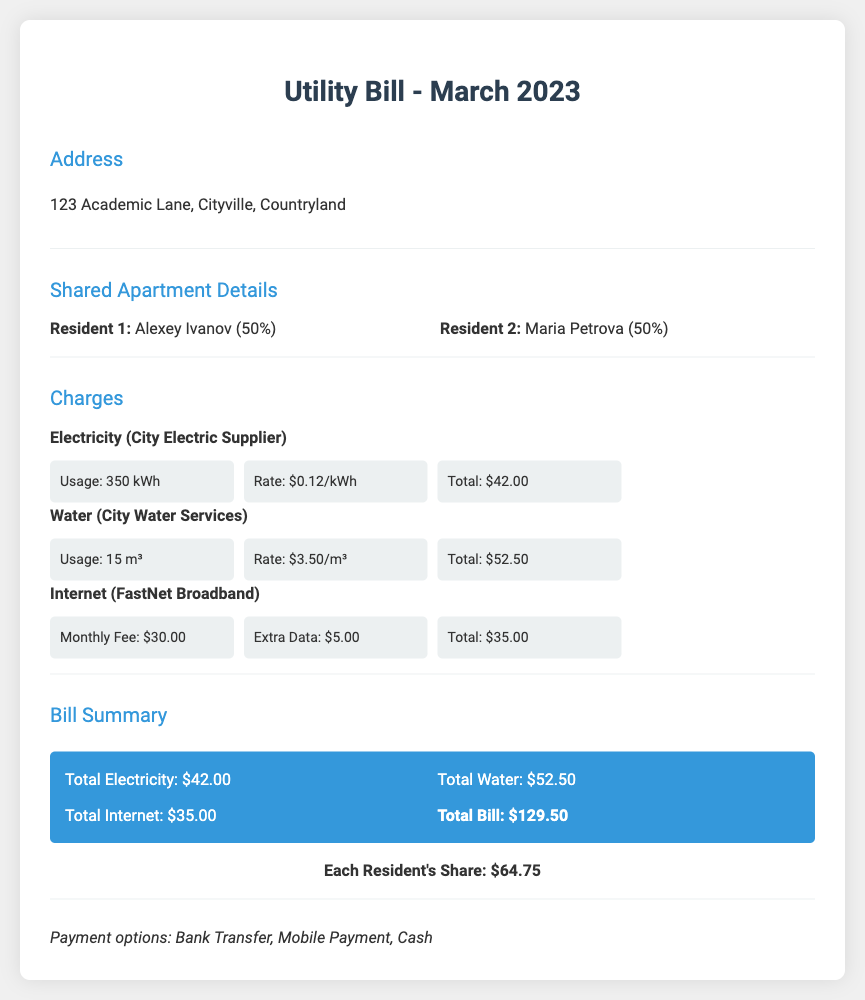What is the total utility bill for March 2023? The total utility bill is the sum of all charges: $42.00 (electricity) + $52.50 (water) + $35.00 (internet) = $129.50.
Answer: $129.50 Who are the residents sharing the apartment? The residents are listed by name along with their share of the apartment: Alexey Ivanov and Maria Petrova, each with a 50% share.
Answer: Alexey Ivanov, Maria Petrova What is the electricity usage in kWh? The document states that the total electricity usage was 350 kWh for the month of March 2023.
Answer: 350 kWh What is the total amount charged for water services? The total for water services is calculated by the provided rate and usage, which is $52.50.
Answer: $52.50 How much does each resident owe for the utility bill? The total bill of $129.50 divided between the two residents shows that each owes $64.75.
Answer: $64.75 What is the rate charged per kWh for electricity? The rate for electricity is explicitly mentioned as $0.12 per kWh.
Answer: $0.12/kWh What additional charge is listed for internet services? An extra data charge of $5.00 is included in the internet service total.
Answer: $5.00 What payment options are available for the bill? The document lists three payment options: Bank Transfer, Mobile Payment, and Cash.
Answer: Bank Transfer, Mobile Payment, Cash What is the total usage in cubic meters for water? The document states that the total water usage for the month is 15 m³.
Answer: 15 m³ 